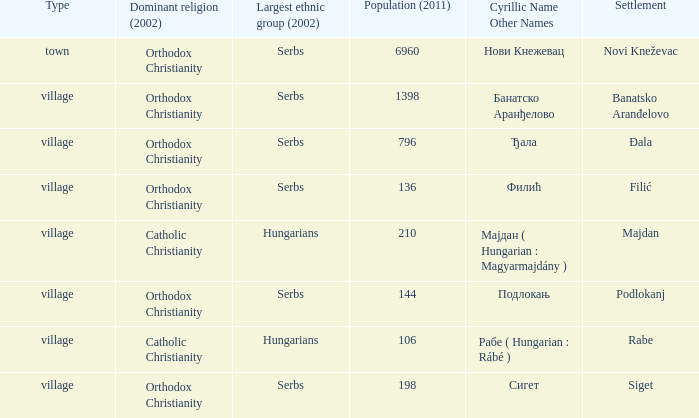How many dominant religions are in đala? 1.0. 